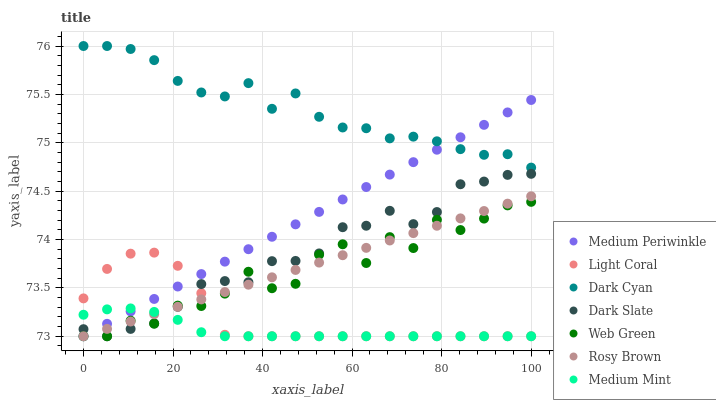Does Medium Mint have the minimum area under the curve?
Answer yes or no. Yes. Does Dark Cyan have the maximum area under the curve?
Answer yes or no. Yes. Does Rosy Brown have the minimum area under the curve?
Answer yes or no. No. Does Rosy Brown have the maximum area under the curve?
Answer yes or no. No. Is Rosy Brown the smoothest?
Answer yes or no. Yes. Is Web Green the roughest?
Answer yes or no. Yes. Is Medium Periwinkle the smoothest?
Answer yes or no. No. Is Medium Periwinkle the roughest?
Answer yes or no. No. Does Medium Mint have the lowest value?
Answer yes or no. Yes. Does Dark Cyan have the lowest value?
Answer yes or no. No. Does Dark Cyan have the highest value?
Answer yes or no. Yes. Does Rosy Brown have the highest value?
Answer yes or no. No. Is Rosy Brown less than Dark Cyan?
Answer yes or no. Yes. Is Dark Cyan greater than Medium Mint?
Answer yes or no. Yes. Does Medium Periwinkle intersect Web Green?
Answer yes or no. Yes. Is Medium Periwinkle less than Web Green?
Answer yes or no. No. Is Medium Periwinkle greater than Web Green?
Answer yes or no. No. Does Rosy Brown intersect Dark Cyan?
Answer yes or no. No. 